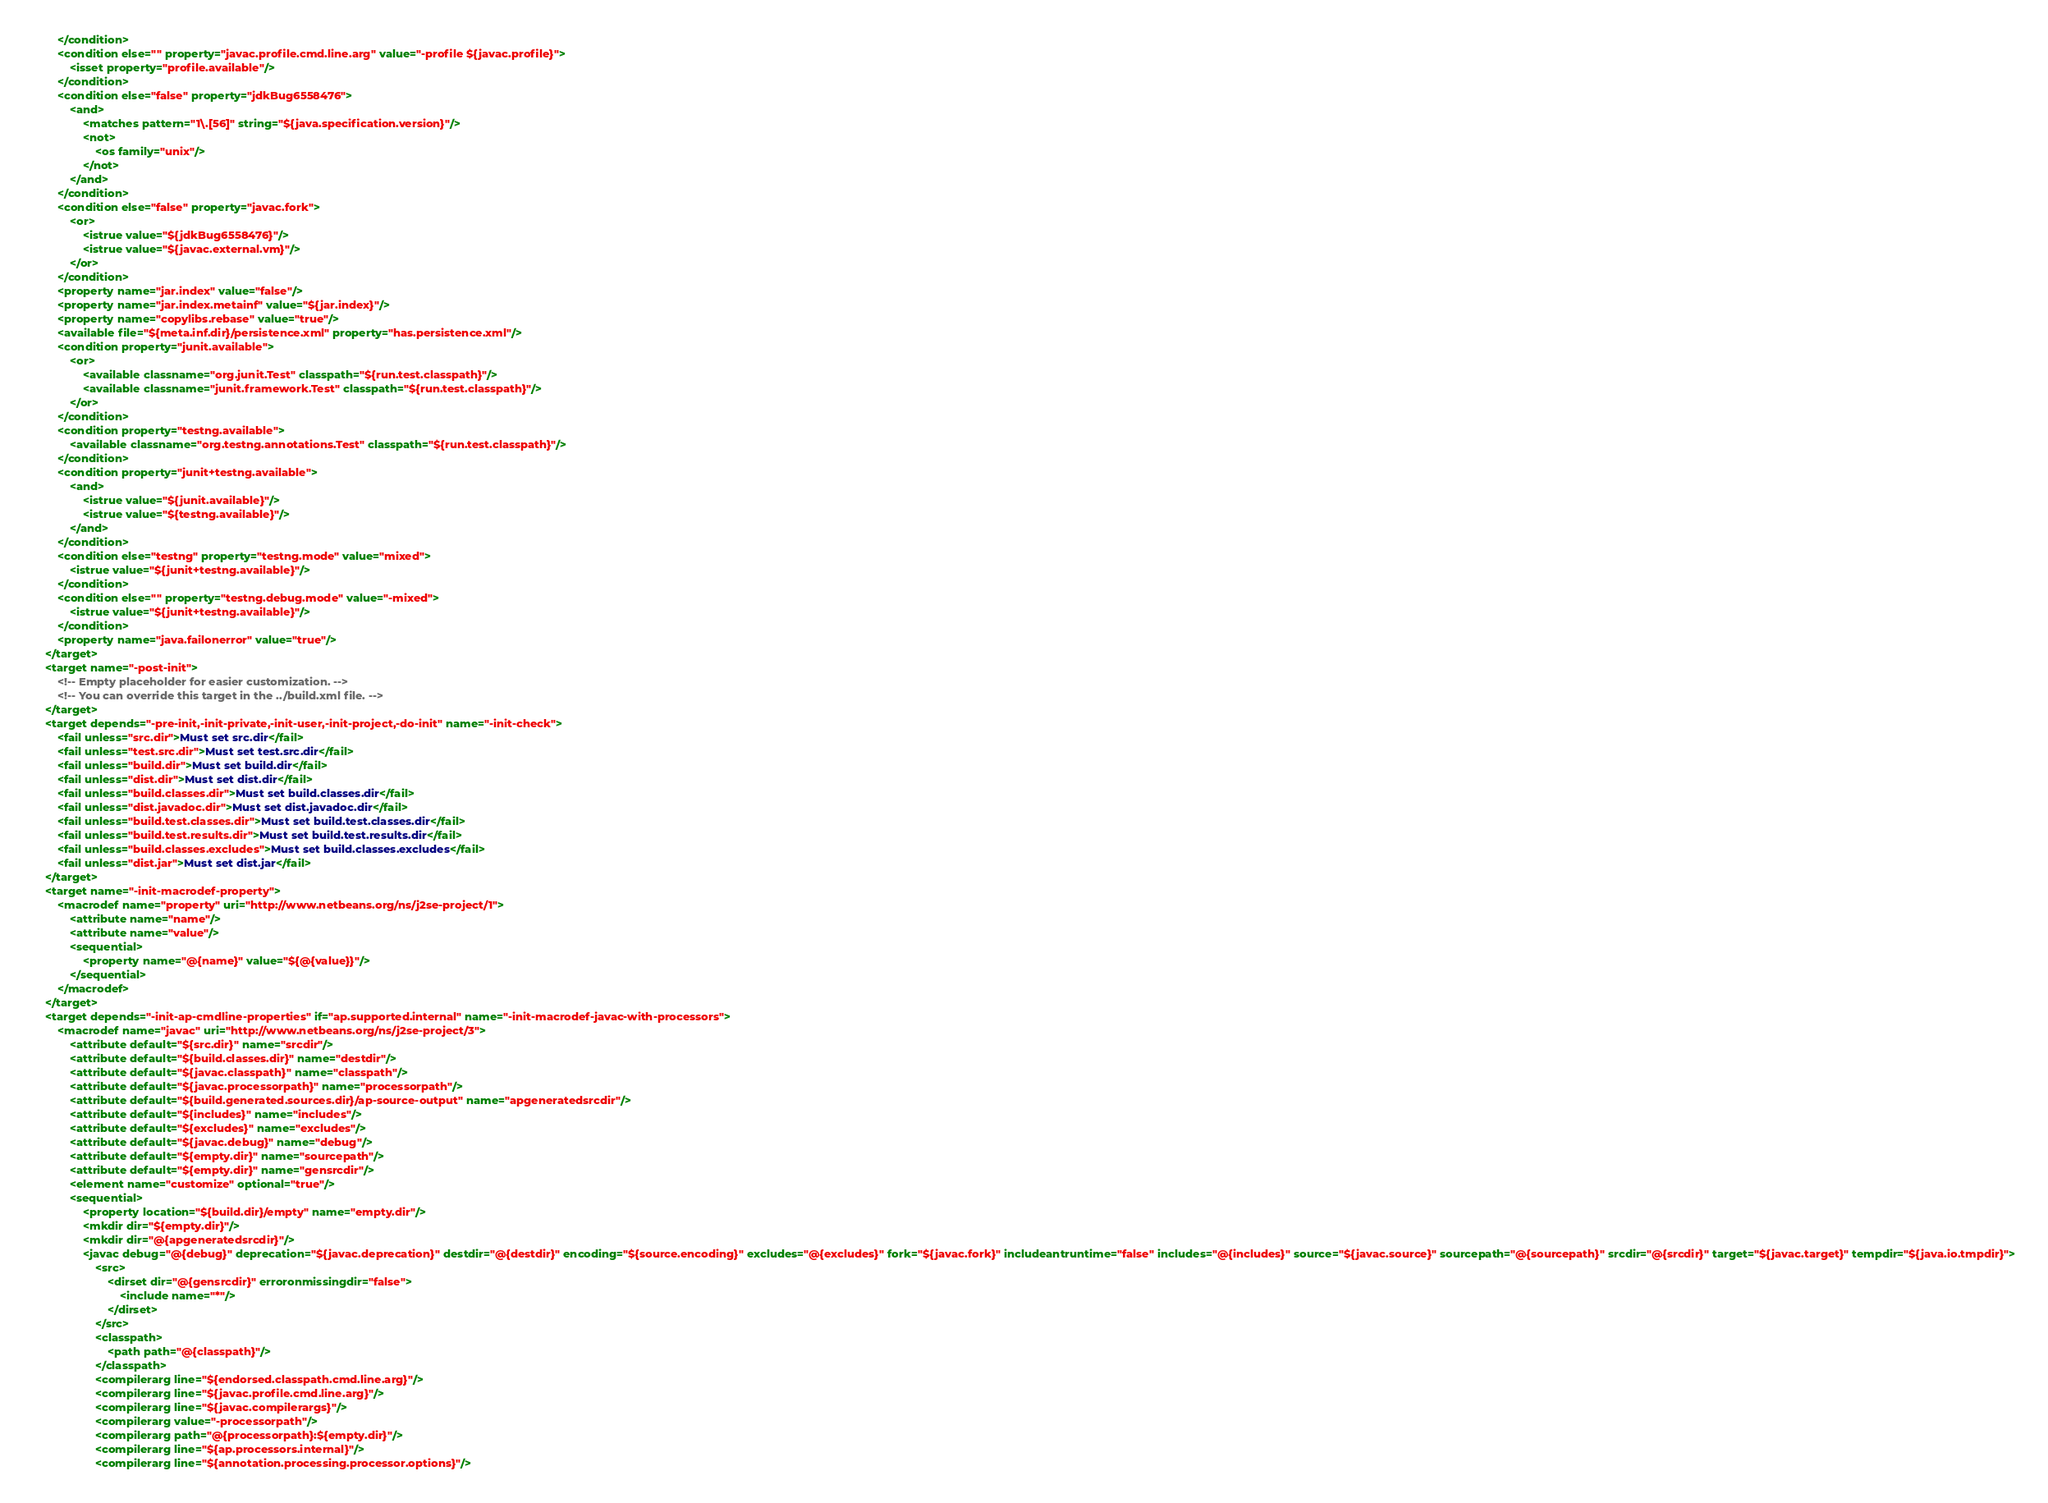Convert code to text. <code><loc_0><loc_0><loc_500><loc_500><_XML_>        </condition>
        <condition else="" property="javac.profile.cmd.line.arg" value="-profile ${javac.profile}">
            <isset property="profile.available"/>
        </condition>
        <condition else="false" property="jdkBug6558476">
            <and>
                <matches pattern="1\.[56]" string="${java.specification.version}"/>
                <not>
                    <os family="unix"/>
                </not>
            </and>
        </condition>
        <condition else="false" property="javac.fork">
            <or>
                <istrue value="${jdkBug6558476}"/>
                <istrue value="${javac.external.vm}"/>
            </or>
        </condition>
        <property name="jar.index" value="false"/>
        <property name="jar.index.metainf" value="${jar.index}"/>
        <property name="copylibs.rebase" value="true"/>
        <available file="${meta.inf.dir}/persistence.xml" property="has.persistence.xml"/>
        <condition property="junit.available">
            <or>
                <available classname="org.junit.Test" classpath="${run.test.classpath}"/>
                <available classname="junit.framework.Test" classpath="${run.test.classpath}"/>
            </or>
        </condition>
        <condition property="testng.available">
            <available classname="org.testng.annotations.Test" classpath="${run.test.classpath}"/>
        </condition>
        <condition property="junit+testng.available">
            <and>
                <istrue value="${junit.available}"/>
                <istrue value="${testng.available}"/>
            </and>
        </condition>
        <condition else="testng" property="testng.mode" value="mixed">
            <istrue value="${junit+testng.available}"/>
        </condition>
        <condition else="" property="testng.debug.mode" value="-mixed">
            <istrue value="${junit+testng.available}"/>
        </condition>
        <property name="java.failonerror" value="true"/>
    </target>
    <target name="-post-init">
        <!-- Empty placeholder for easier customization. -->
        <!-- You can override this target in the ../build.xml file. -->
    </target>
    <target depends="-pre-init,-init-private,-init-user,-init-project,-do-init" name="-init-check">
        <fail unless="src.dir">Must set src.dir</fail>
        <fail unless="test.src.dir">Must set test.src.dir</fail>
        <fail unless="build.dir">Must set build.dir</fail>
        <fail unless="dist.dir">Must set dist.dir</fail>
        <fail unless="build.classes.dir">Must set build.classes.dir</fail>
        <fail unless="dist.javadoc.dir">Must set dist.javadoc.dir</fail>
        <fail unless="build.test.classes.dir">Must set build.test.classes.dir</fail>
        <fail unless="build.test.results.dir">Must set build.test.results.dir</fail>
        <fail unless="build.classes.excludes">Must set build.classes.excludes</fail>
        <fail unless="dist.jar">Must set dist.jar</fail>
    </target>
    <target name="-init-macrodef-property">
        <macrodef name="property" uri="http://www.netbeans.org/ns/j2se-project/1">
            <attribute name="name"/>
            <attribute name="value"/>
            <sequential>
                <property name="@{name}" value="${@{value}}"/>
            </sequential>
        </macrodef>
    </target>
    <target depends="-init-ap-cmdline-properties" if="ap.supported.internal" name="-init-macrodef-javac-with-processors">
        <macrodef name="javac" uri="http://www.netbeans.org/ns/j2se-project/3">
            <attribute default="${src.dir}" name="srcdir"/>
            <attribute default="${build.classes.dir}" name="destdir"/>
            <attribute default="${javac.classpath}" name="classpath"/>
            <attribute default="${javac.processorpath}" name="processorpath"/>
            <attribute default="${build.generated.sources.dir}/ap-source-output" name="apgeneratedsrcdir"/>
            <attribute default="${includes}" name="includes"/>
            <attribute default="${excludes}" name="excludes"/>
            <attribute default="${javac.debug}" name="debug"/>
            <attribute default="${empty.dir}" name="sourcepath"/>
            <attribute default="${empty.dir}" name="gensrcdir"/>
            <element name="customize" optional="true"/>
            <sequential>
                <property location="${build.dir}/empty" name="empty.dir"/>
                <mkdir dir="${empty.dir}"/>
                <mkdir dir="@{apgeneratedsrcdir}"/>
                <javac debug="@{debug}" deprecation="${javac.deprecation}" destdir="@{destdir}" encoding="${source.encoding}" excludes="@{excludes}" fork="${javac.fork}" includeantruntime="false" includes="@{includes}" source="${javac.source}" sourcepath="@{sourcepath}" srcdir="@{srcdir}" target="${javac.target}" tempdir="${java.io.tmpdir}">
                    <src>
                        <dirset dir="@{gensrcdir}" erroronmissingdir="false">
                            <include name="*"/>
                        </dirset>
                    </src>
                    <classpath>
                        <path path="@{classpath}"/>
                    </classpath>
                    <compilerarg line="${endorsed.classpath.cmd.line.arg}"/>
                    <compilerarg line="${javac.profile.cmd.line.arg}"/>
                    <compilerarg line="${javac.compilerargs}"/>
                    <compilerarg value="-processorpath"/>
                    <compilerarg path="@{processorpath}:${empty.dir}"/>
                    <compilerarg line="${ap.processors.internal}"/>
                    <compilerarg line="${annotation.processing.processor.options}"/></code> 